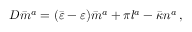<formula> <loc_0><loc_0><loc_500><loc_500>D { \bar { m } } ^ { a } = ( { \bar { \varepsilon } } - \varepsilon ) { \bar { m } } ^ { a } + \pi l ^ { a } - { \bar { \kappa } } n ^ { a } \, ,</formula> 